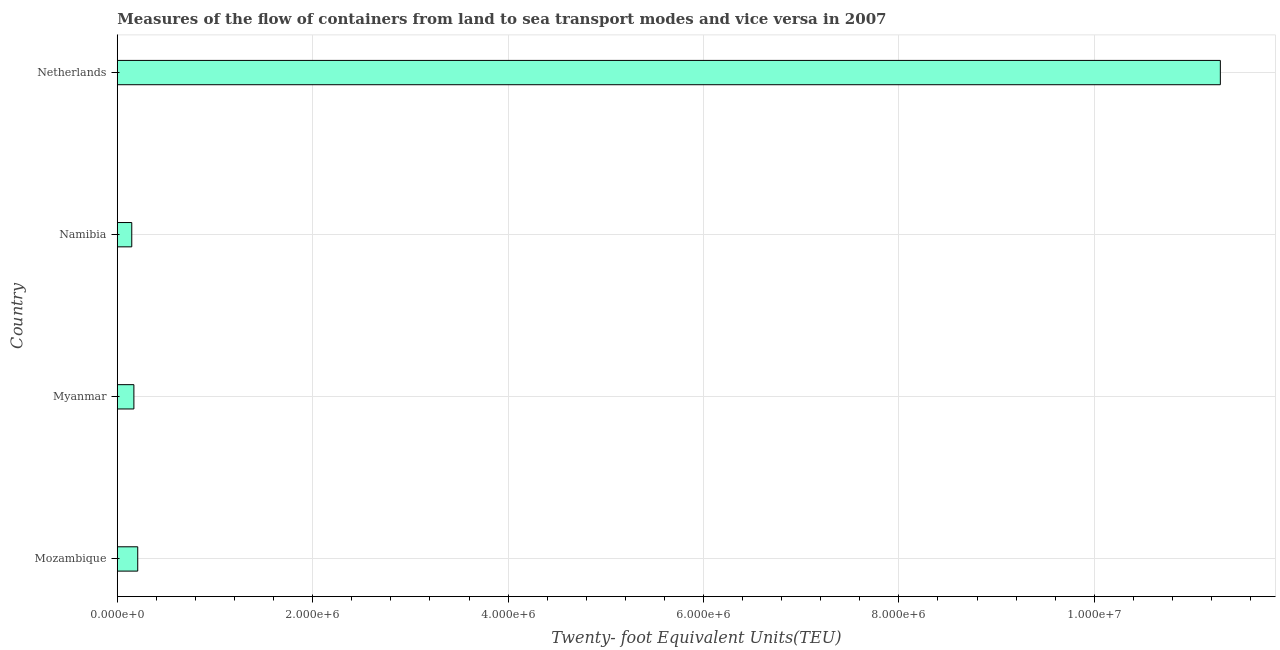What is the title of the graph?
Provide a short and direct response. Measures of the flow of containers from land to sea transport modes and vice versa in 2007. What is the label or title of the X-axis?
Provide a short and direct response. Twenty- foot Equivalent Units(TEU). What is the label or title of the Y-axis?
Give a very brief answer. Country. What is the container port traffic in Myanmar?
Make the answer very short. 1.70e+05. Across all countries, what is the maximum container port traffic?
Make the answer very short. 1.13e+07. Across all countries, what is the minimum container port traffic?
Make the answer very short. 1.48e+05. In which country was the container port traffic minimum?
Your answer should be very brief. Namibia. What is the sum of the container port traffic?
Give a very brief answer. 1.18e+07. What is the difference between the container port traffic in Mozambique and Netherlands?
Your answer should be very brief. -1.11e+07. What is the average container port traffic per country?
Give a very brief answer. 2.95e+06. What is the median container port traffic?
Keep it short and to the point. 1.90e+05. What is the ratio of the container port traffic in Myanmar to that in Namibia?
Your answer should be compact. 1.15. Is the difference between the container port traffic in Myanmar and Netherlands greater than the difference between any two countries?
Your response must be concise. No. What is the difference between the highest and the second highest container port traffic?
Your response must be concise. 1.11e+07. What is the difference between the highest and the lowest container port traffic?
Offer a terse response. 1.11e+07. In how many countries, is the container port traffic greater than the average container port traffic taken over all countries?
Keep it short and to the point. 1. How many bars are there?
Offer a very short reply. 4. Are the values on the major ticks of X-axis written in scientific E-notation?
Keep it short and to the point. Yes. What is the Twenty- foot Equivalent Units(TEU) of Mozambique?
Your answer should be very brief. 2.09e+05. What is the Twenty- foot Equivalent Units(TEU) in Myanmar?
Provide a succinct answer. 1.70e+05. What is the Twenty- foot Equivalent Units(TEU) of Namibia?
Your answer should be compact. 1.48e+05. What is the Twenty- foot Equivalent Units(TEU) in Netherlands?
Make the answer very short. 1.13e+07. What is the difference between the Twenty- foot Equivalent Units(TEU) in Mozambique and Myanmar?
Keep it short and to the point. 3.93e+04. What is the difference between the Twenty- foot Equivalent Units(TEU) in Mozambique and Namibia?
Your response must be concise. 6.11e+04. What is the difference between the Twenty- foot Equivalent Units(TEU) in Mozambique and Netherlands?
Your answer should be very brief. -1.11e+07. What is the difference between the Twenty- foot Equivalent Units(TEU) in Myanmar and Namibia?
Your response must be concise. 2.18e+04. What is the difference between the Twenty- foot Equivalent Units(TEU) in Myanmar and Netherlands?
Keep it short and to the point. -1.11e+07. What is the difference between the Twenty- foot Equivalent Units(TEU) in Namibia and Netherlands?
Your answer should be compact. -1.11e+07. What is the ratio of the Twenty- foot Equivalent Units(TEU) in Mozambique to that in Myanmar?
Offer a terse response. 1.23. What is the ratio of the Twenty- foot Equivalent Units(TEU) in Mozambique to that in Namibia?
Offer a very short reply. 1.41. What is the ratio of the Twenty- foot Equivalent Units(TEU) in Mozambique to that in Netherlands?
Give a very brief answer. 0.02. What is the ratio of the Twenty- foot Equivalent Units(TEU) in Myanmar to that in Namibia?
Your answer should be very brief. 1.15. What is the ratio of the Twenty- foot Equivalent Units(TEU) in Myanmar to that in Netherlands?
Ensure brevity in your answer.  0.01. What is the ratio of the Twenty- foot Equivalent Units(TEU) in Namibia to that in Netherlands?
Your answer should be very brief. 0.01. 